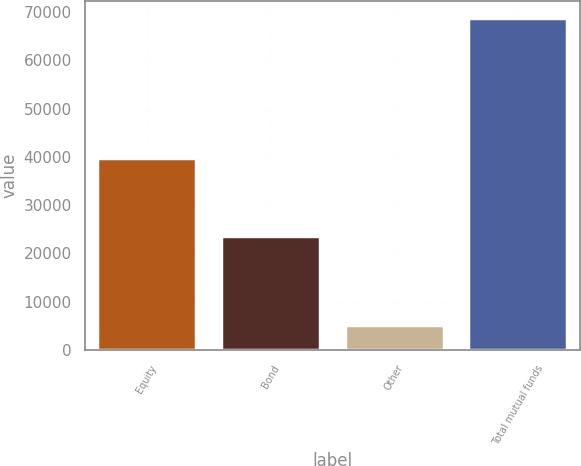<chart> <loc_0><loc_0><loc_500><loc_500><bar_chart><fcel>Equity<fcel>Bond<fcel>Other<fcel>Total mutual funds<nl><fcel>39806<fcel>23700<fcel>5241<fcel>68747<nl></chart> 